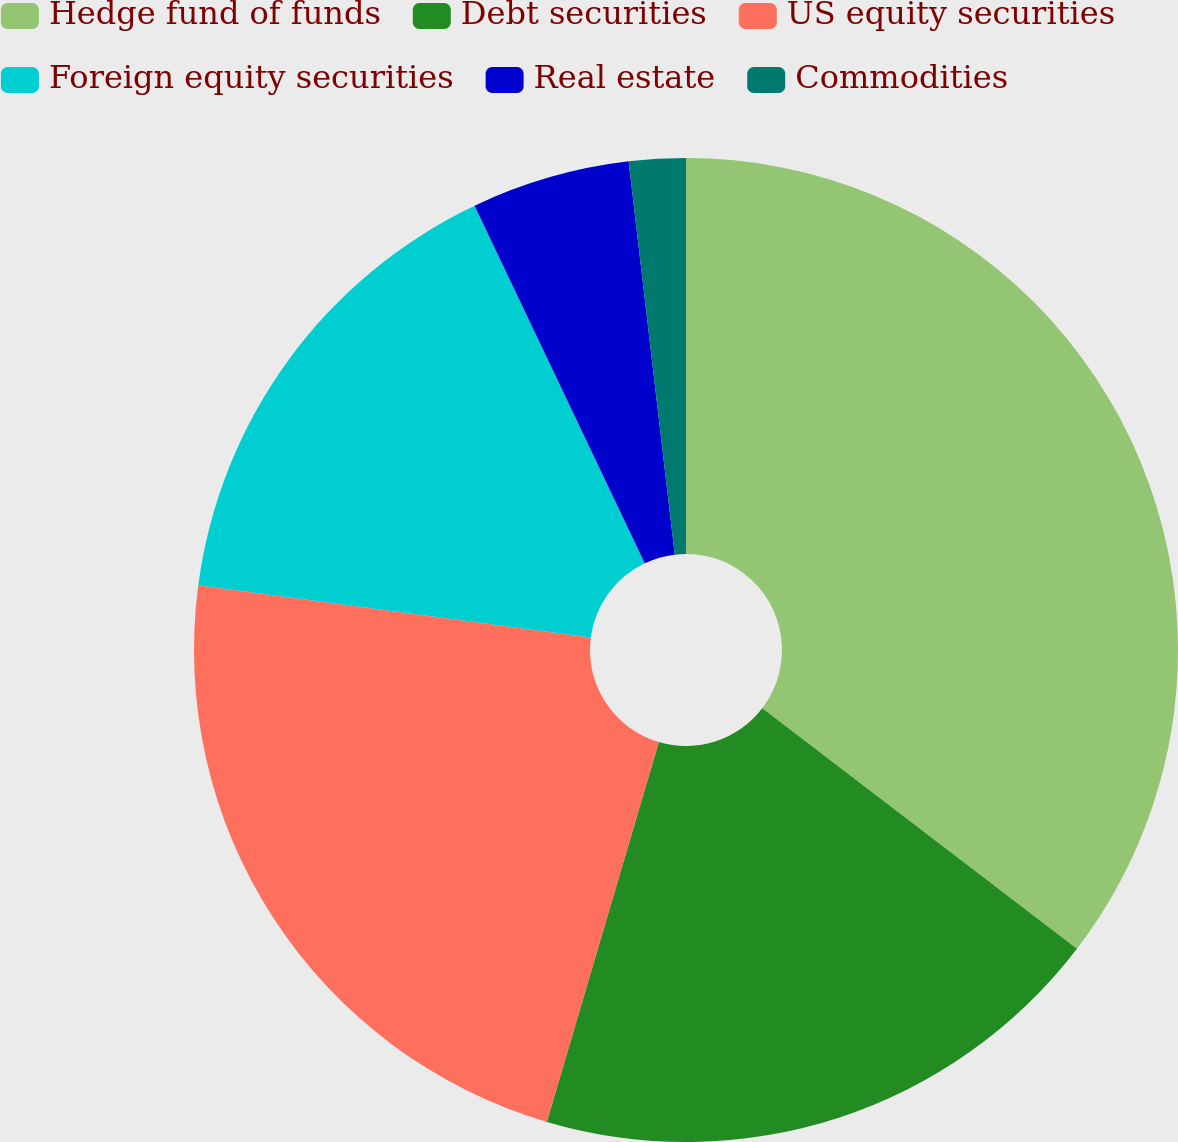<chart> <loc_0><loc_0><loc_500><loc_500><pie_chart><fcel>Hedge fund of funds<fcel>Debt securities<fcel>US equity securities<fcel>Foreign equity securities<fcel>Real estate<fcel>Commodities<nl><fcel>35.38%<fcel>19.18%<fcel>22.53%<fcel>15.83%<fcel>5.21%<fcel>1.86%<nl></chart> 